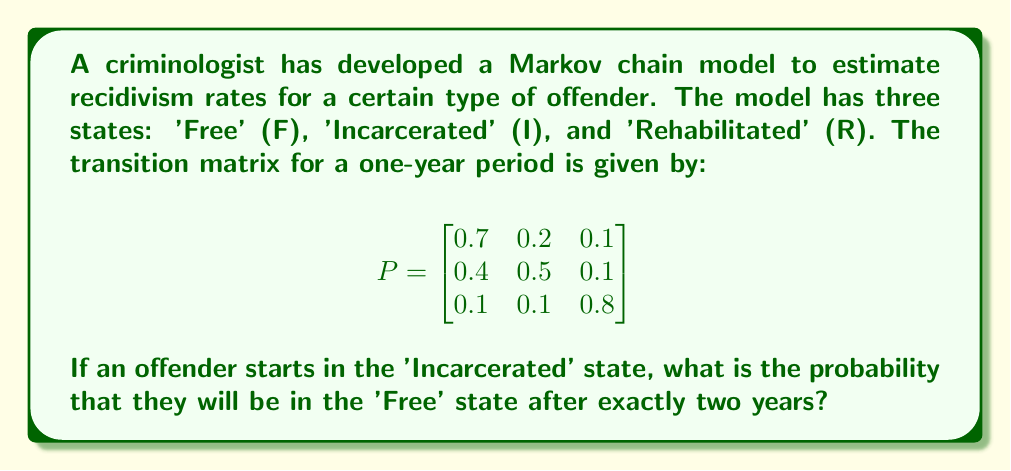Solve this math problem. To solve this problem, we need to use the properties of Markov chains and matrix multiplication. Let's break it down step-by-step:

1) The initial state vector for an offender starting in the 'Incarcerated' state is:

   $$v_0 = \begin{bmatrix} 0 \\ 1 \\ 0 \end{bmatrix}$$

2) To find the probability distribution after two years, we need to multiply the transition matrix by itself and then by the initial state vector:

   $$v_2 = P^2 \cdot v_0$$

3) Let's calculate $P^2$:

   $$P^2 = P \cdot P = \begin{bmatrix}
   0.7 & 0.2 & 0.1 \\
   0.4 & 0.5 & 0.1 \\
   0.1 & 0.1 & 0.8
   \end{bmatrix} \cdot \begin{bmatrix}
   0.7 & 0.2 & 0.1 \\
   0.4 & 0.5 & 0.1 \\
   0.1 & 0.1 & 0.8
   \end{bmatrix}$$

4) Performing the matrix multiplication:

   $$P^2 = \begin{bmatrix}
   0.58 & 0.23 & 0.19 \\
   0.53 & 0.33 & 0.14 \\
   0.19 & 0.17 & 0.64
   \end{bmatrix}$$

5) Now, we multiply $P^2$ by the initial state vector:

   $$v_2 = P^2 \cdot v_0 = \begin{bmatrix}
   0.58 & 0.23 & 0.19 \\
   0.53 & 0.33 & 0.14 \\
   0.19 & 0.17 & 0.64
   \end{bmatrix} \cdot \begin{bmatrix} 0 \\ 1 \\ 0 \end{bmatrix}$$

6) This gives us:

   $$v_2 = \begin{bmatrix} 0.53 \\ 0.33 \\ 0.14 \end{bmatrix}$$

7) The probability of being in the 'Free' state after two years is given by the first element of this vector, which is 0.53 or 53%.
Answer: The probability that an offender who starts in the 'Incarcerated' state will be in the 'Free' state after exactly two years is 0.53 or 53%. 